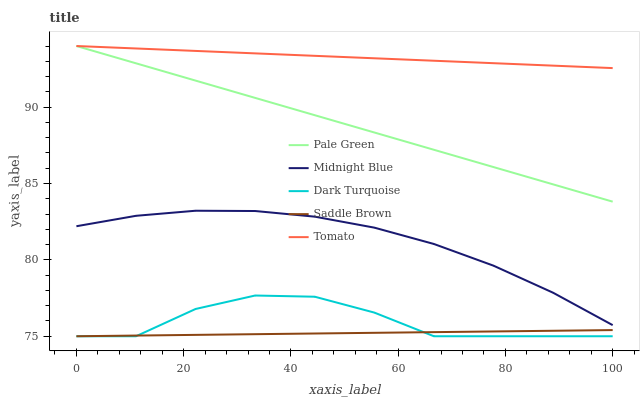Does Saddle Brown have the minimum area under the curve?
Answer yes or no. Yes. Does Tomato have the maximum area under the curve?
Answer yes or no. Yes. Does Dark Turquoise have the minimum area under the curve?
Answer yes or no. No. Does Dark Turquoise have the maximum area under the curve?
Answer yes or no. No. Is Pale Green the smoothest?
Answer yes or no. Yes. Is Dark Turquoise the roughest?
Answer yes or no. Yes. Is Dark Turquoise the smoothest?
Answer yes or no. No. Is Pale Green the roughest?
Answer yes or no. No. Does Dark Turquoise have the lowest value?
Answer yes or no. Yes. Does Pale Green have the lowest value?
Answer yes or no. No. Does Pale Green have the highest value?
Answer yes or no. Yes. Does Dark Turquoise have the highest value?
Answer yes or no. No. Is Saddle Brown less than Tomato?
Answer yes or no. Yes. Is Midnight Blue greater than Dark Turquoise?
Answer yes or no. Yes. Does Dark Turquoise intersect Saddle Brown?
Answer yes or no. Yes. Is Dark Turquoise less than Saddle Brown?
Answer yes or no. No. Is Dark Turquoise greater than Saddle Brown?
Answer yes or no. No. Does Saddle Brown intersect Tomato?
Answer yes or no. No. 